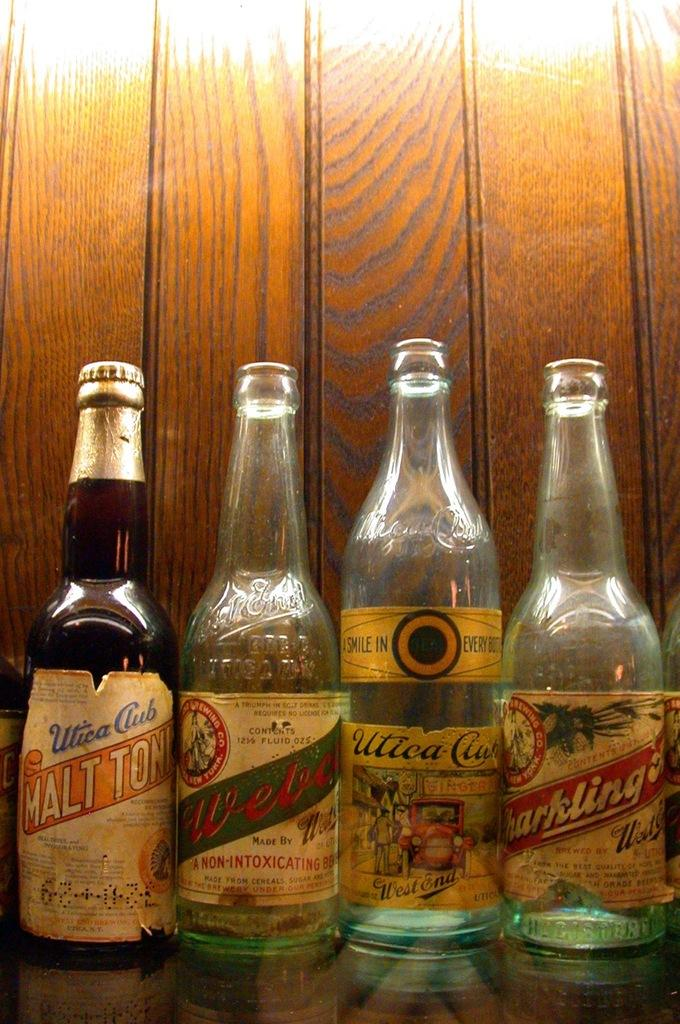<image>
Provide a brief description of the given image. Several bottles are lined up including some of the brand Utica Club. 